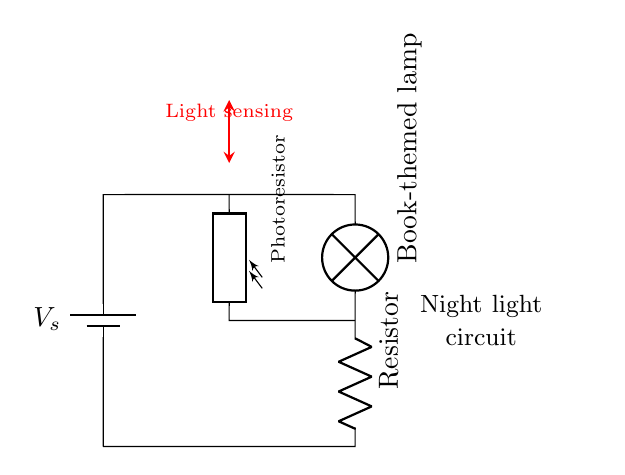What is the primary function of the photoresistor in this circuit? The primary function of the photoresistor is to sense light levels. When light levels change, the resistance alters, affecting the circuit's operation, specifically the lamp's brightness.
Answer: Light sensing How many components are present in the circuit? The circuit diagram includes five main components: a battery, a lamp, a resistor, a photoresistor, and connecting wires. Adding these gives a total of five components visually represented.
Answer: Five What is the role of the resistor in this circuit? The resistor limits the current flowing through the circuit, ensuring the lamp functions properly without drawing too much power or overheating. This is essential for protecting the lamp and maintaining a safe circuit operation.
Answer: Current limiting What type of circuit is represented? The circuit is a simple series circuit, where all components are connected in a single path, and the same current flows through each component. The series nature is evident as all elements connect one after another.
Answer: Simple series What happens to the lamp when the light level is high? When the light level is high, the photoresistor's resistance decreases, which usually allows more current to flow. This typically results in the lamp being brighter or fully illuminated, depending on the configuration.
Answer: Lamp brightens Which component is responsible for adjusting the brightness of the lamp? The photoresistor is responsible for adjusting the brightness of the lamp. As it responds to light changes, it alters its resistance, which in turn affects the current and how the lamp operates.
Answer: Photoresistor 